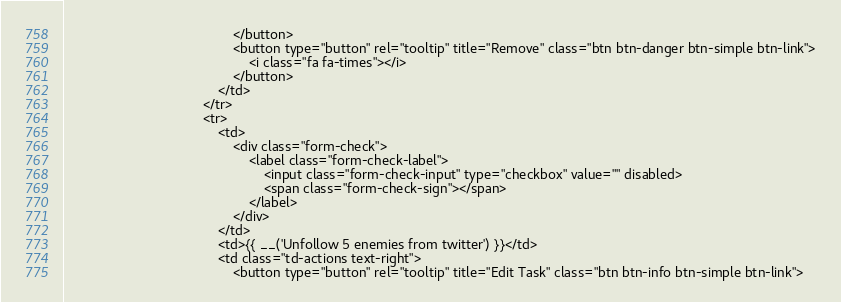<code> <loc_0><loc_0><loc_500><loc_500><_PHP_>                                            </button>
                                            <button type="button" rel="tooltip" title="Remove" class="btn btn-danger btn-simple btn-link">
                                                <i class="fa fa-times"></i>
                                            </button>
                                        </td>
                                    </tr>
                                    <tr>
                                        <td>
                                            <div class="form-check">
                                                <label class="form-check-label">
                                                    <input class="form-check-input" type="checkbox" value="" disabled>
                                                    <span class="form-check-sign"></span>
                                                </label>
                                            </div>
                                        </td>
                                        <td>{{ __('Unfollow 5 enemies from twitter') }}</td>
                                        <td class="td-actions text-right">
                                            <button type="button" rel="tooltip" title="Edit Task" class="btn btn-info btn-simple btn-link"></code> 